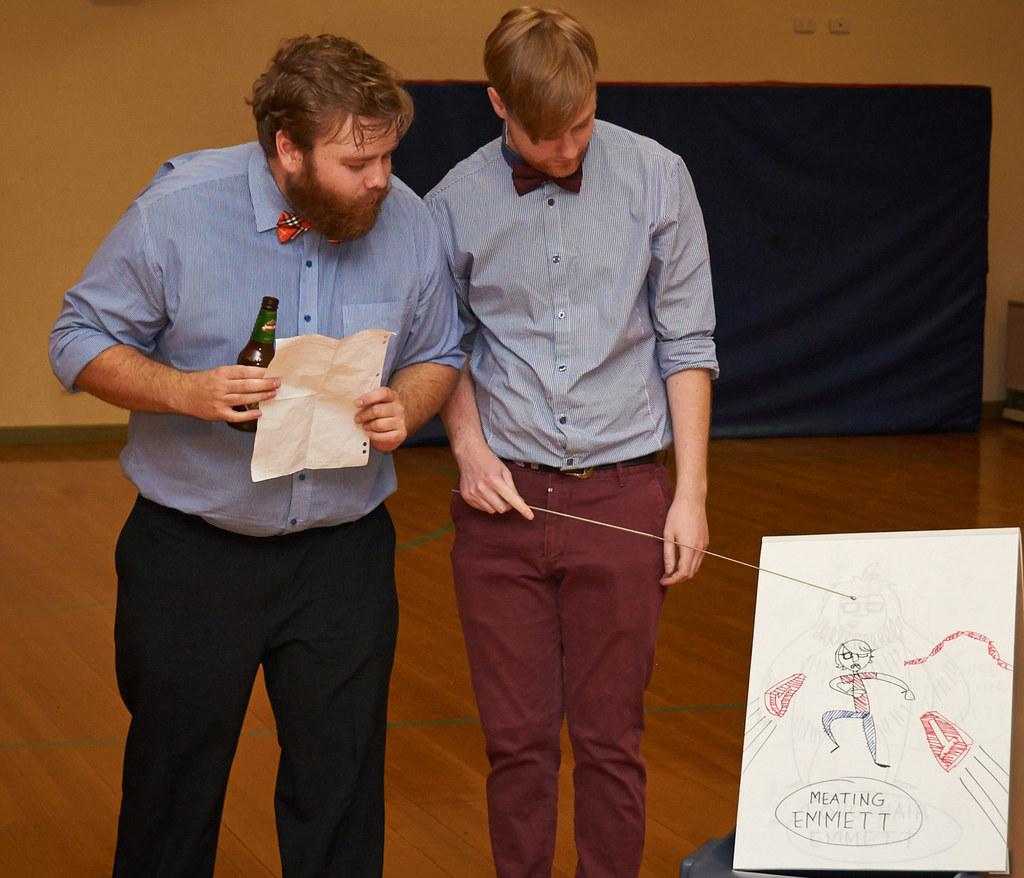How many people are in the image? There are two persons standing in the center of the image. What can be seen in the background of the image? There is a wall in the background of the image. What is visible at the bottom of the image? There is a floor visible at the bottom of the image. What type of desk can be seen in the image? There is no desk present in the image. Can you tell me how angry the persons in the image are? The image does not convey any emotions, so it is not possible to determine the level of anger or any other emotion. 